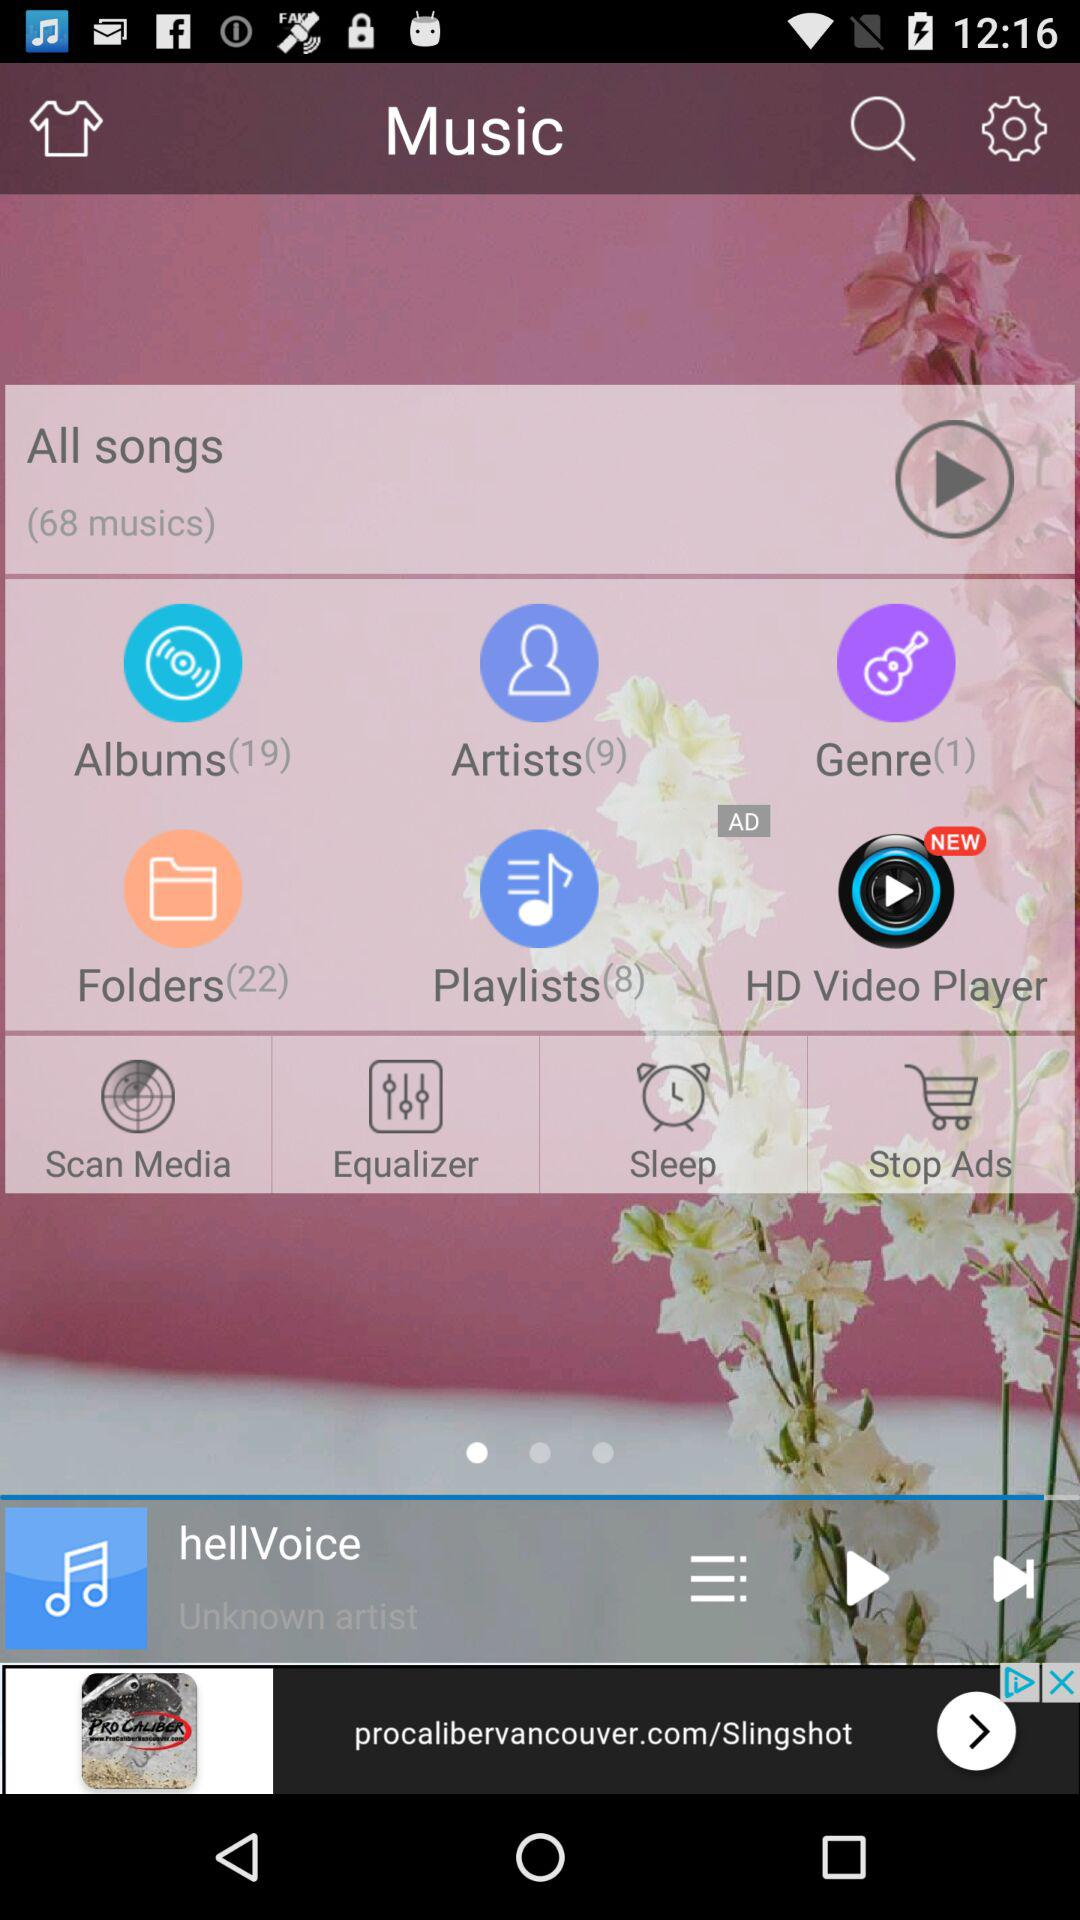How many more items are in the Folders section than the Artists section?
Answer the question using a single word or phrase. 13 